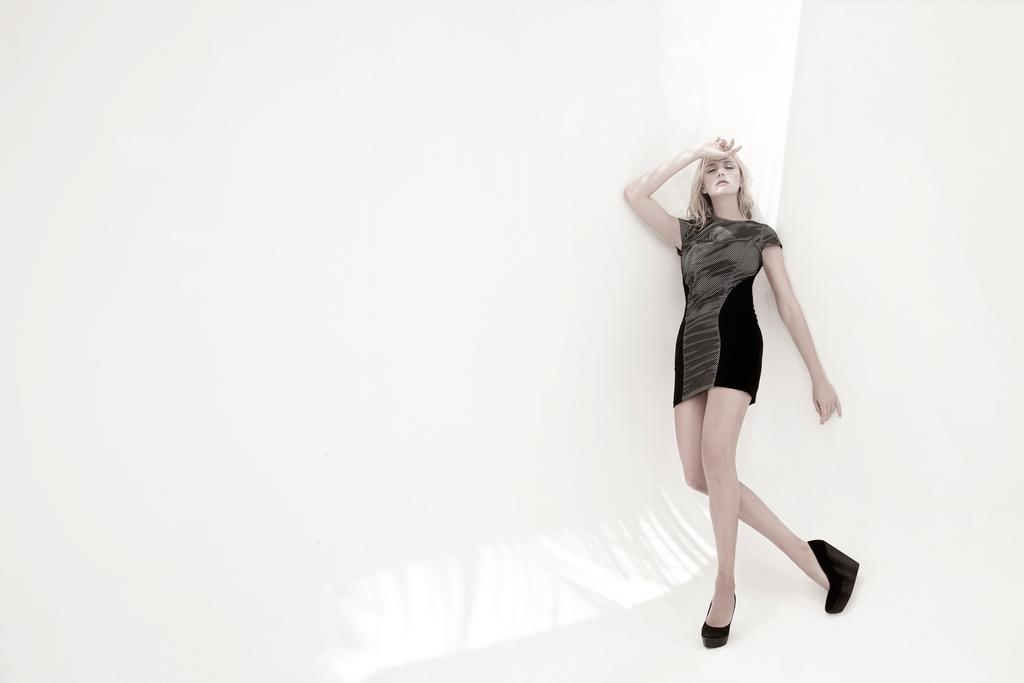Who is the main subject in the image? There is a woman in the image. What is the woman wearing? The woman is wearing a black dress. What is the woman doing in the image? The woman is standing. What color is the background of the image? The background of the image is white. Can you see any trees or yaks in the image? No, there are no trees or yaks present in the image. 